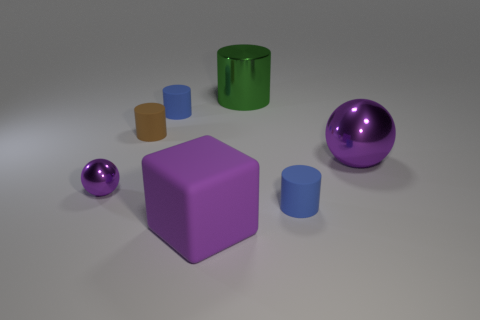Subtract 1 cylinders. How many cylinders are left? 3 Add 1 large metal spheres. How many objects exist? 8 Subtract all cylinders. How many objects are left? 3 Add 7 purple shiny spheres. How many purple shiny spheres exist? 9 Subtract 1 purple blocks. How many objects are left? 6 Subtract all small cyan metallic cylinders. Subtract all green objects. How many objects are left? 6 Add 1 rubber blocks. How many rubber blocks are left? 2 